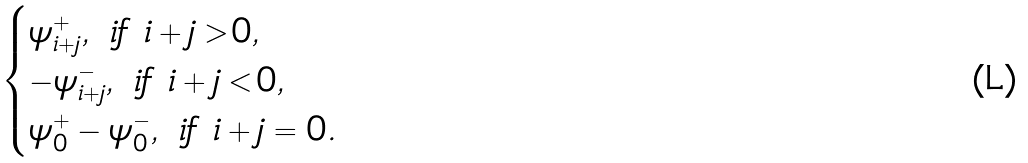<formula> <loc_0><loc_0><loc_500><loc_500>\begin{cases} \psi ^ { + } _ { i + j } , \text { if } i + j > 0 , \\ - \psi ^ { - } _ { i + j } , \text { if } i + j < 0 , \\ \psi ^ { + } _ { 0 } - \psi ^ { - } _ { 0 } , \text { if } i + j = 0 . \end{cases}</formula> 